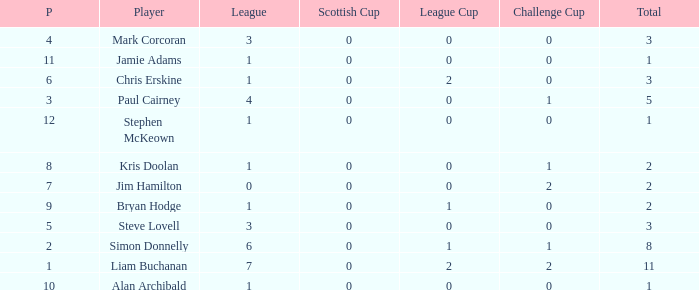How many points did player 7 score in the challenge cup? 1.0. 